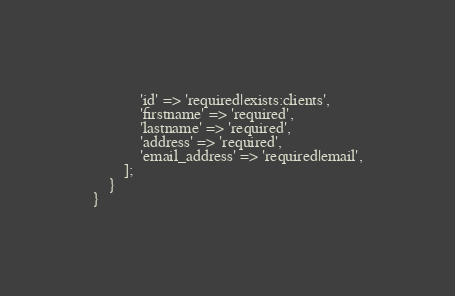Convert code to text. <code><loc_0><loc_0><loc_500><loc_500><_PHP_>            'id' => 'required|exists:clients',
            'firstname' => 'required',
            'lastname' => 'required',
            'address' => 'required',
            'email_address' => 'required|email',
        ];
    }
}
</code> 